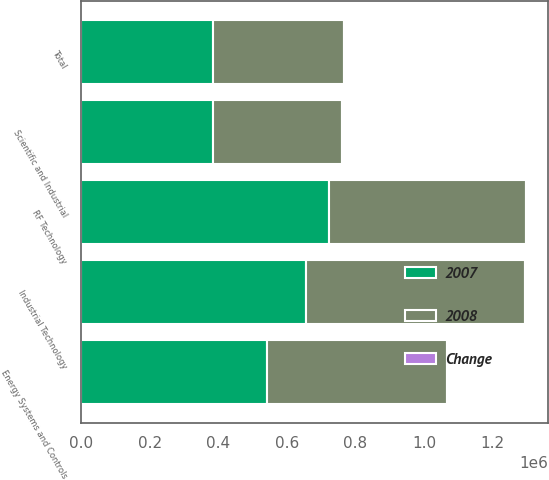Convert chart. <chart><loc_0><loc_0><loc_500><loc_500><stacked_bar_chart><ecel><fcel>Industrial Technology<fcel>Energy Systems and Controls<fcel>Scientific and Industrial<fcel>RF Technology<fcel>Total<nl><fcel>2007<fcel>656176<fcel>541472<fcel>383543<fcel>722670<fcel>383543<nl><fcel>2008<fcel>639348<fcel>525899<fcel>377653<fcel>575100<fcel>383543<nl><fcel>Change<fcel>2.6<fcel>3<fcel>1.6<fcel>25.7<fcel>8.8<nl></chart> 